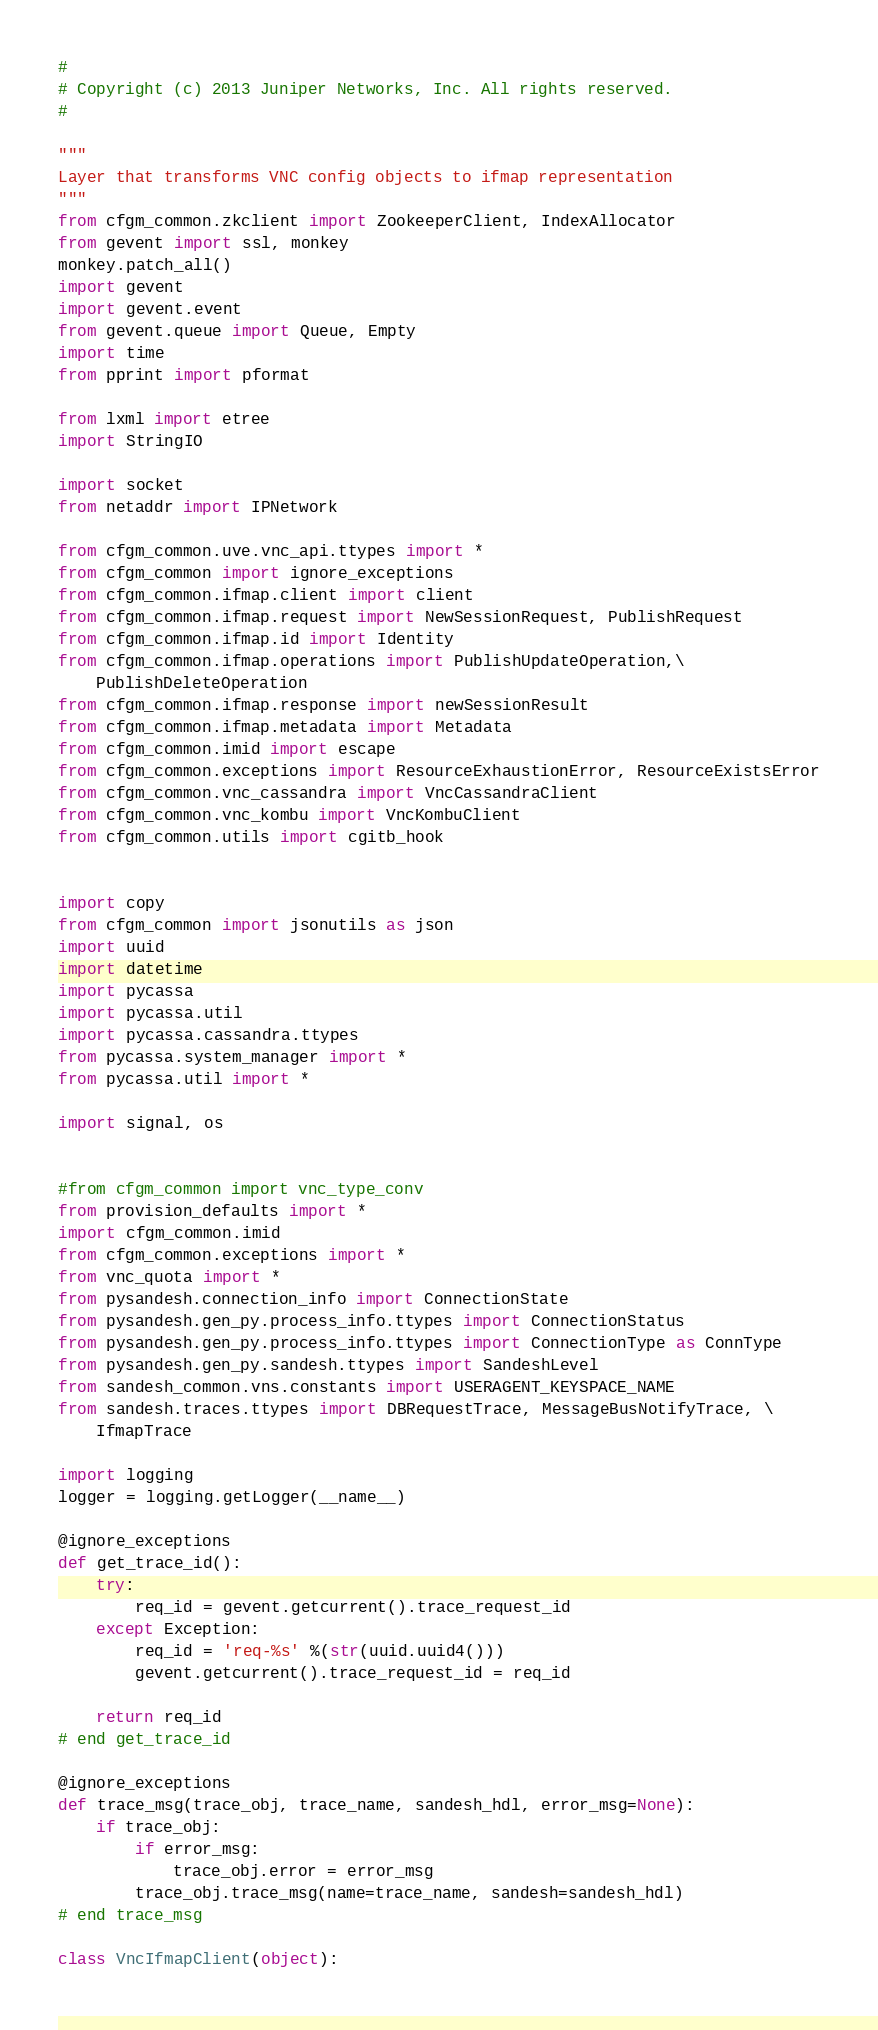Convert code to text. <code><loc_0><loc_0><loc_500><loc_500><_Python_>#
# Copyright (c) 2013 Juniper Networks, Inc. All rights reserved.
#

"""
Layer that transforms VNC config objects to ifmap representation
"""
from cfgm_common.zkclient import ZookeeperClient, IndexAllocator
from gevent import ssl, monkey
monkey.patch_all()
import gevent
import gevent.event
from gevent.queue import Queue, Empty
import time
from pprint import pformat

from lxml import etree
import StringIO

import socket
from netaddr import IPNetwork

from cfgm_common.uve.vnc_api.ttypes import *
from cfgm_common import ignore_exceptions
from cfgm_common.ifmap.client import client
from cfgm_common.ifmap.request import NewSessionRequest, PublishRequest
from cfgm_common.ifmap.id import Identity
from cfgm_common.ifmap.operations import PublishUpdateOperation,\
    PublishDeleteOperation
from cfgm_common.ifmap.response import newSessionResult
from cfgm_common.ifmap.metadata import Metadata
from cfgm_common.imid import escape
from cfgm_common.exceptions import ResourceExhaustionError, ResourceExistsError
from cfgm_common.vnc_cassandra import VncCassandraClient
from cfgm_common.vnc_kombu import VncKombuClient
from cfgm_common.utils import cgitb_hook


import copy
from cfgm_common import jsonutils as json
import uuid
import datetime
import pycassa
import pycassa.util
import pycassa.cassandra.ttypes
from pycassa.system_manager import *
from pycassa.util import *

import signal, os


#from cfgm_common import vnc_type_conv
from provision_defaults import *
import cfgm_common.imid
from cfgm_common.exceptions import *
from vnc_quota import *
from pysandesh.connection_info import ConnectionState
from pysandesh.gen_py.process_info.ttypes import ConnectionStatus
from pysandesh.gen_py.process_info.ttypes import ConnectionType as ConnType
from pysandesh.gen_py.sandesh.ttypes import SandeshLevel
from sandesh_common.vns.constants import USERAGENT_KEYSPACE_NAME
from sandesh.traces.ttypes import DBRequestTrace, MessageBusNotifyTrace, \
    IfmapTrace

import logging
logger = logging.getLogger(__name__)

@ignore_exceptions
def get_trace_id():
    try:
        req_id = gevent.getcurrent().trace_request_id
    except Exception:
        req_id = 'req-%s' %(str(uuid.uuid4()))
        gevent.getcurrent().trace_request_id = req_id

    return req_id
# end get_trace_id

@ignore_exceptions
def trace_msg(trace_obj, trace_name, sandesh_hdl, error_msg=None):
    if trace_obj:
        if error_msg:
            trace_obj.error = error_msg
        trace_obj.trace_msg(name=trace_name, sandesh=sandesh_hdl)
# end trace_msg

class VncIfmapClient(object):
</code> 